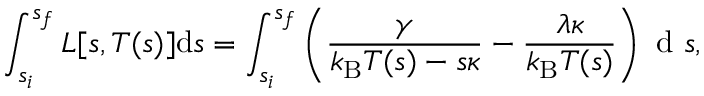<formula> <loc_0><loc_0><loc_500><loc_500>\int _ { s _ { i } } ^ { s _ { f } } L [ s , T ( s ) ] d s = \int _ { s _ { i } } ^ { s _ { f } } \left ( \frac { \gamma } { k _ { B } T ( s ) - s \kappa } - \frac { \lambda \kappa } { k _ { B } T ( s ) } \right ) d s ,</formula> 